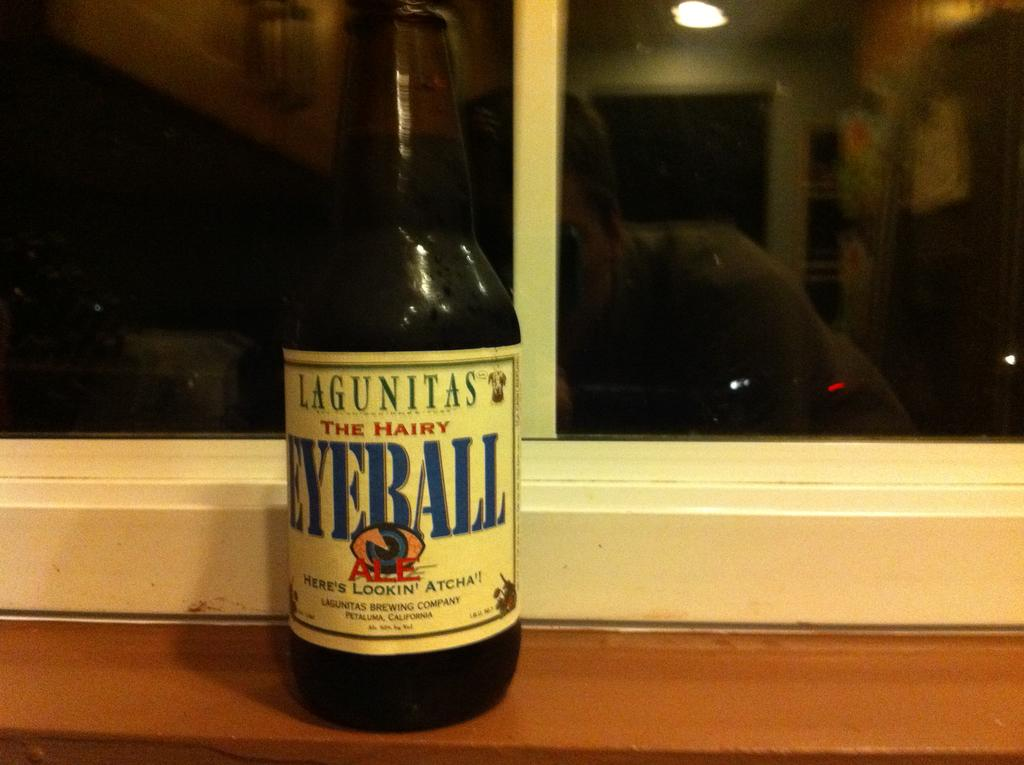<image>
Summarize the visual content of the image. A bottle of The Hairy Eyeball sitting on the window seal. 